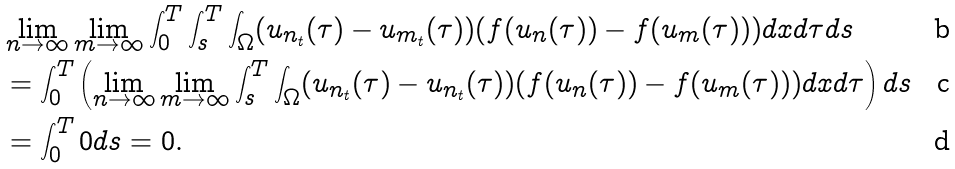<formula> <loc_0><loc_0><loc_500><loc_500>& \lim _ { n \to \infty } \lim _ { m \to \infty } \int _ { 0 } ^ { T } \int _ { s } ^ { T } \int _ { \Omega } ( u _ { n _ { t } } ( \tau ) - u _ { m _ { t } } ( \tau ) ) ( f ( u _ { n } ( \tau ) ) - f ( u _ { m } ( \tau ) ) ) d x d \tau d s \\ & = \int _ { 0 } ^ { T } \left ( \lim _ { n \to \infty } \lim _ { m \to \infty } \int _ { s } ^ { T } \int _ { \Omega } ( u _ { n _ { t } } ( \tau ) - u _ { n _ { t } } ( \tau ) ) ( f ( u _ { n } ( \tau ) ) - f ( u _ { m } ( \tau ) ) ) d x d \tau \right ) d s \\ & = \int _ { 0 } ^ { T } 0 d s = 0 .</formula> 